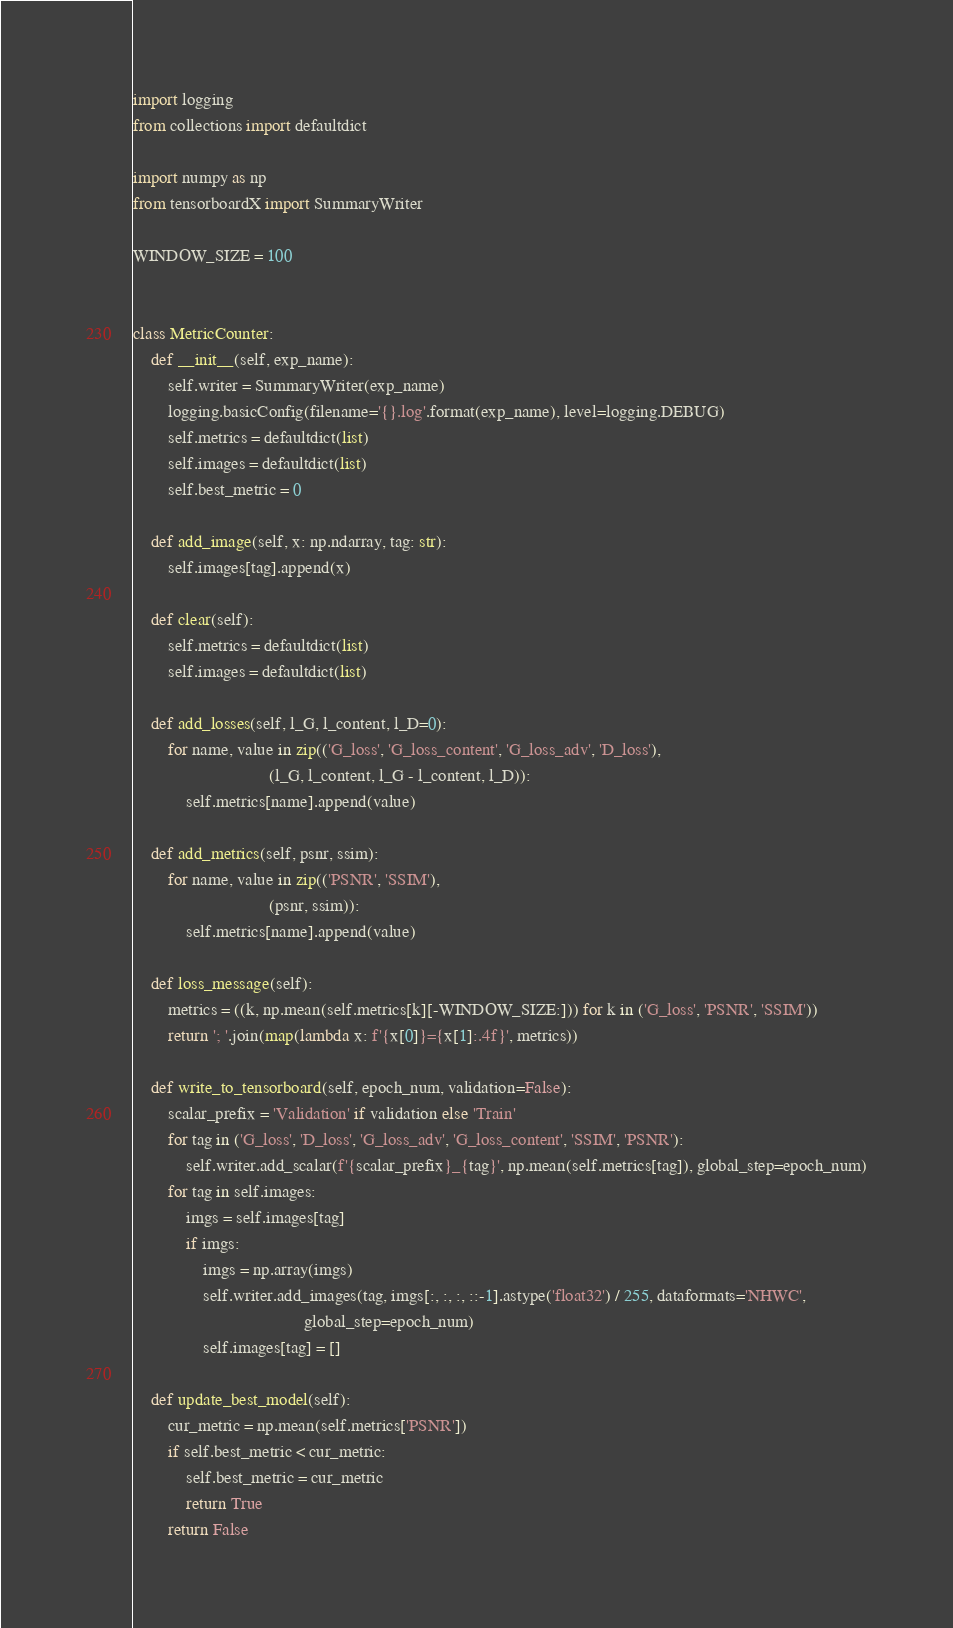<code> <loc_0><loc_0><loc_500><loc_500><_Python_>import logging
from collections import defaultdict

import numpy as np
from tensorboardX import SummaryWriter

WINDOW_SIZE = 100


class MetricCounter:
    def __init__(self, exp_name):
        self.writer = SummaryWriter(exp_name)
        logging.basicConfig(filename='{}.log'.format(exp_name), level=logging.DEBUG)
        self.metrics = defaultdict(list)
        self.images = defaultdict(list)
        self.best_metric = 0

    def add_image(self, x: np.ndarray, tag: str):
        self.images[tag].append(x)

    def clear(self):
        self.metrics = defaultdict(list)
        self.images = defaultdict(list)

    def add_losses(self, l_G, l_content, l_D=0):
        for name, value in zip(('G_loss', 'G_loss_content', 'G_loss_adv', 'D_loss'),
                               (l_G, l_content, l_G - l_content, l_D)):
            self.metrics[name].append(value)

    def add_metrics(self, psnr, ssim):
        for name, value in zip(('PSNR', 'SSIM'),
                               (psnr, ssim)):
            self.metrics[name].append(value)

    def loss_message(self):
        metrics = ((k, np.mean(self.metrics[k][-WINDOW_SIZE:])) for k in ('G_loss', 'PSNR', 'SSIM'))
        return '; '.join(map(lambda x: f'{x[0]}={x[1]:.4f}', metrics))

    def write_to_tensorboard(self, epoch_num, validation=False):
        scalar_prefix = 'Validation' if validation else 'Train'
        for tag in ('G_loss', 'D_loss', 'G_loss_adv', 'G_loss_content', 'SSIM', 'PSNR'):
            self.writer.add_scalar(f'{scalar_prefix}_{tag}', np.mean(self.metrics[tag]), global_step=epoch_num)
        for tag in self.images:
            imgs = self.images[tag]
            if imgs:
                imgs = np.array(imgs)
                self.writer.add_images(tag, imgs[:, :, :, ::-1].astype('float32') / 255, dataformats='NHWC',
                                       global_step=epoch_num)
                self.images[tag] = []

    def update_best_model(self):
        cur_metric = np.mean(self.metrics['PSNR'])
        if self.best_metric < cur_metric:
            self.best_metric = cur_metric
            return True
        return False
</code> 